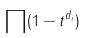<formula> <loc_0><loc_0><loc_500><loc_500>\prod ( 1 - t ^ { d _ { i } } )</formula> 